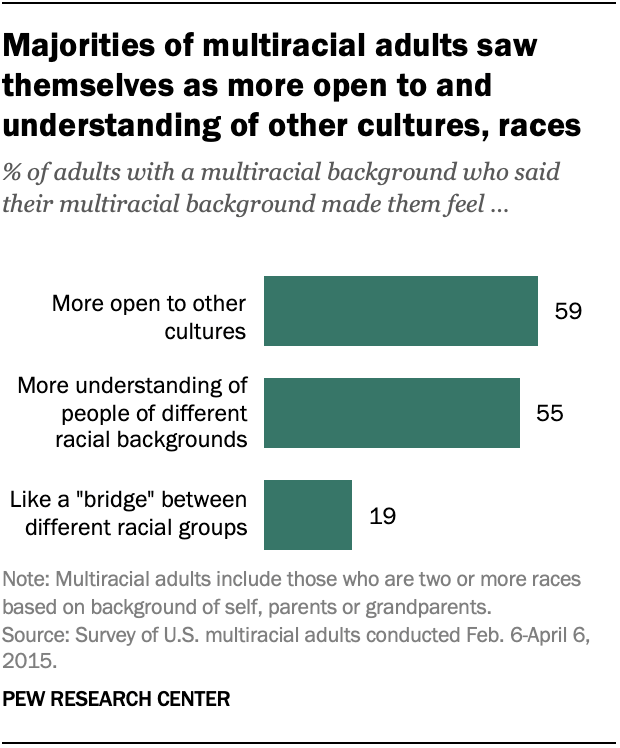Draw attention to some important aspects in this diagram. The highest value for bats is 59. The average of all the bars is 44.3 